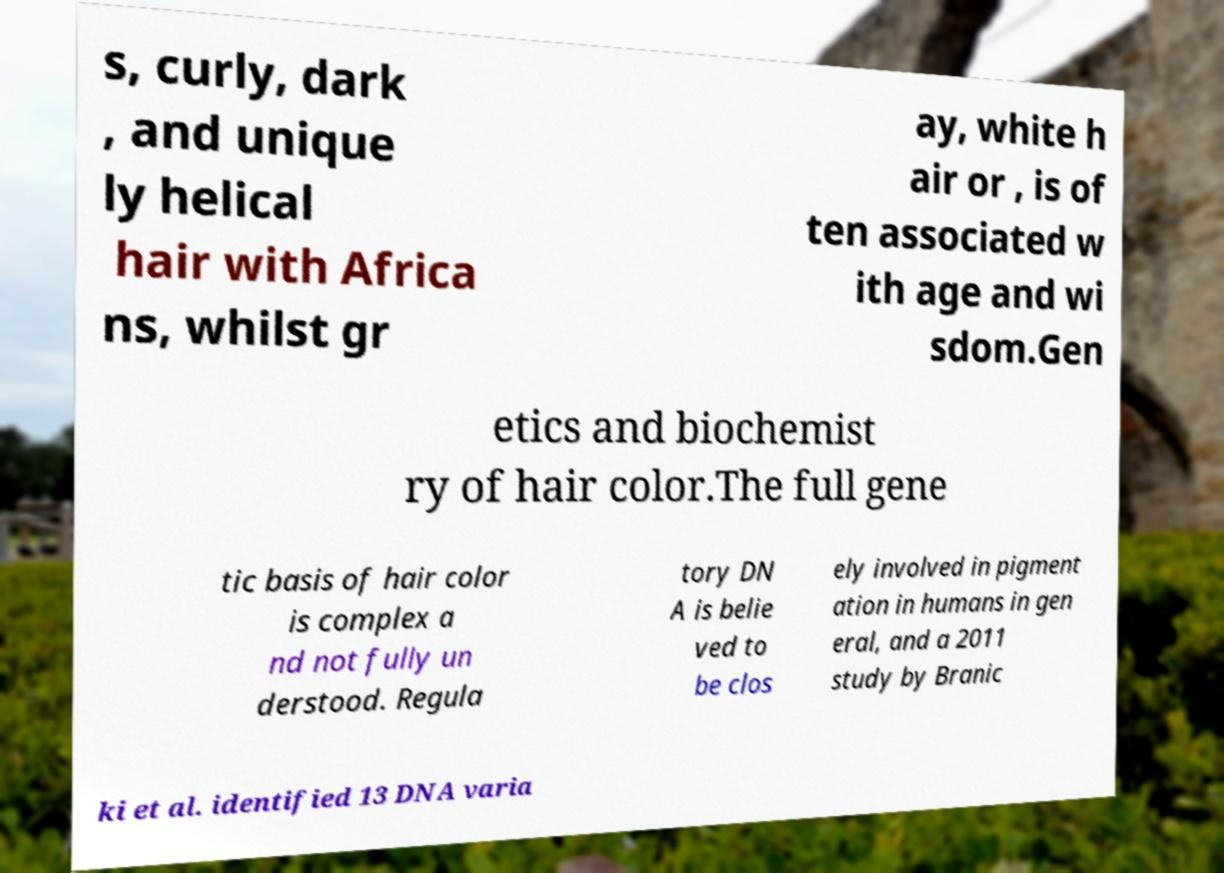For documentation purposes, I need the text within this image transcribed. Could you provide that? s, curly, dark , and unique ly helical hair with Africa ns, whilst gr ay, white h air or , is of ten associated w ith age and wi sdom.Gen etics and biochemist ry of hair color.The full gene tic basis of hair color is complex a nd not fully un derstood. Regula tory DN A is belie ved to be clos ely involved in pigment ation in humans in gen eral, and a 2011 study by Branic ki et al. identified 13 DNA varia 